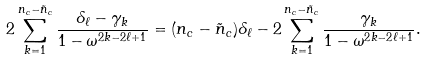<formula> <loc_0><loc_0><loc_500><loc_500>2 \sum _ { k = 1 } ^ { n _ { c } - \tilde { n } _ { c } } \frac { \delta _ { \ell } - \gamma _ { k } } { 1 - \omega ^ { 2 k - 2 \ell + 1 } } = ( n _ { c } - \tilde { n } _ { c } ) \delta _ { \ell } - 2 \sum _ { k = 1 } ^ { n _ { c } - \tilde { n } _ { c } } \frac { \gamma _ { k } } { 1 - \omega ^ { 2 k - 2 \ell + 1 } } .</formula> 